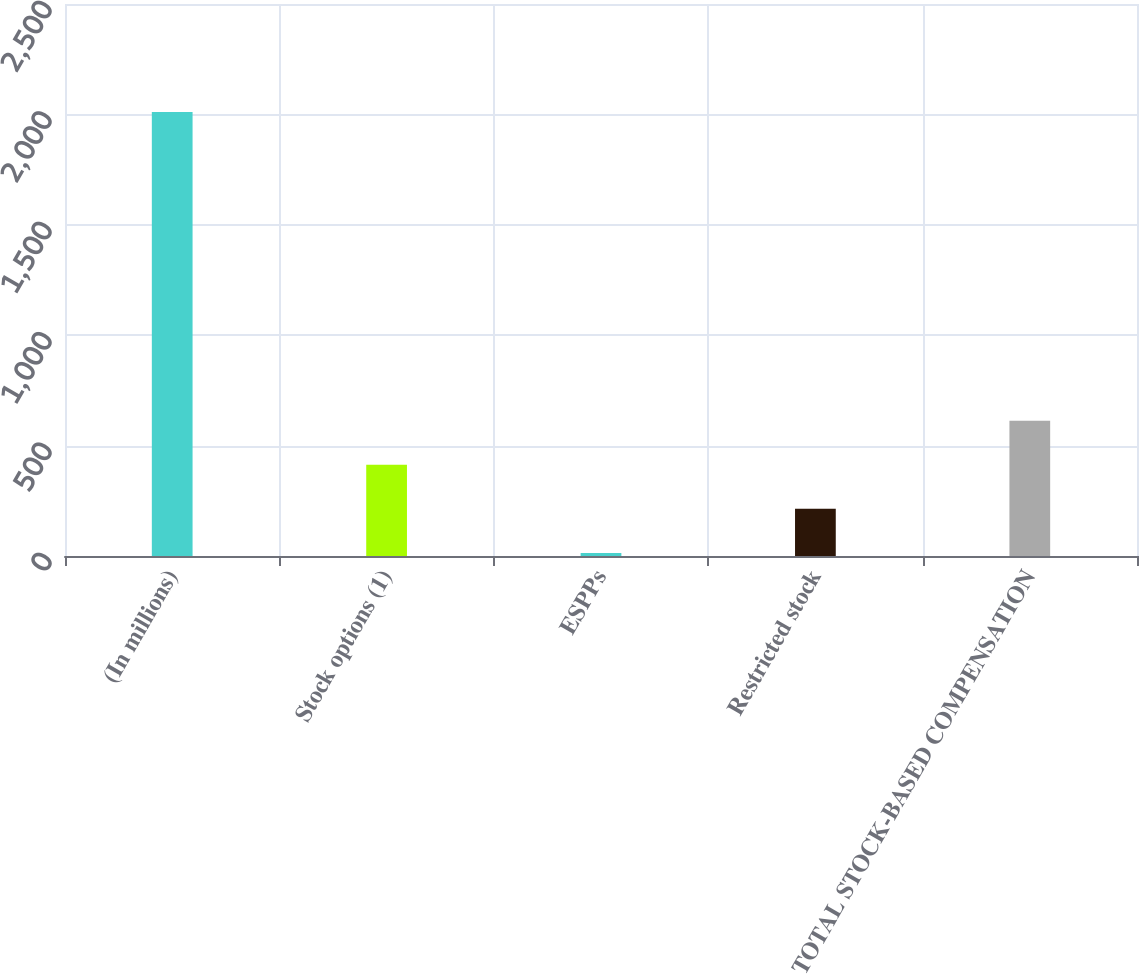Convert chart. <chart><loc_0><loc_0><loc_500><loc_500><bar_chart><fcel>(In millions)<fcel>Stock options (1)<fcel>ESPPs<fcel>Restricted stock<fcel>TOTAL STOCK-BASED COMPENSATION<nl><fcel>2011<fcel>413.4<fcel>14<fcel>213.7<fcel>613.1<nl></chart> 